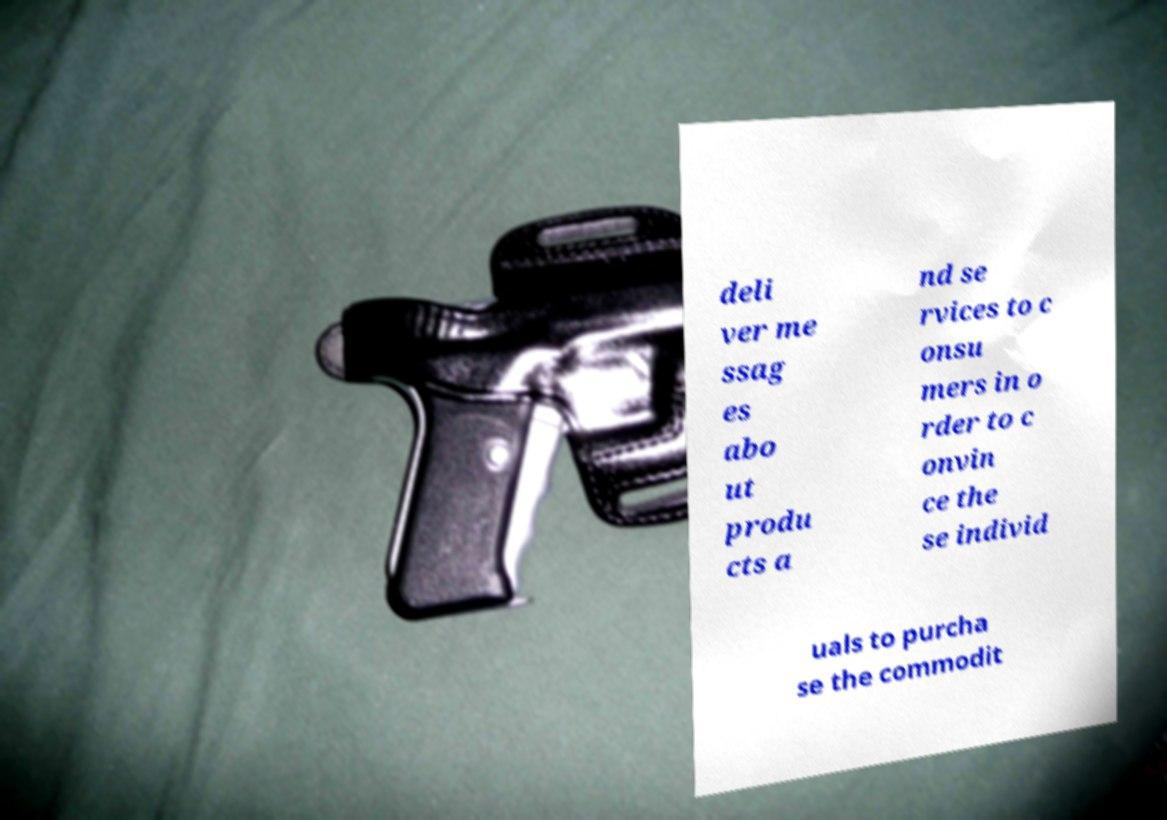Could you assist in decoding the text presented in this image and type it out clearly? deli ver me ssag es abo ut produ cts a nd se rvices to c onsu mers in o rder to c onvin ce the se individ uals to purcha se the commodit 